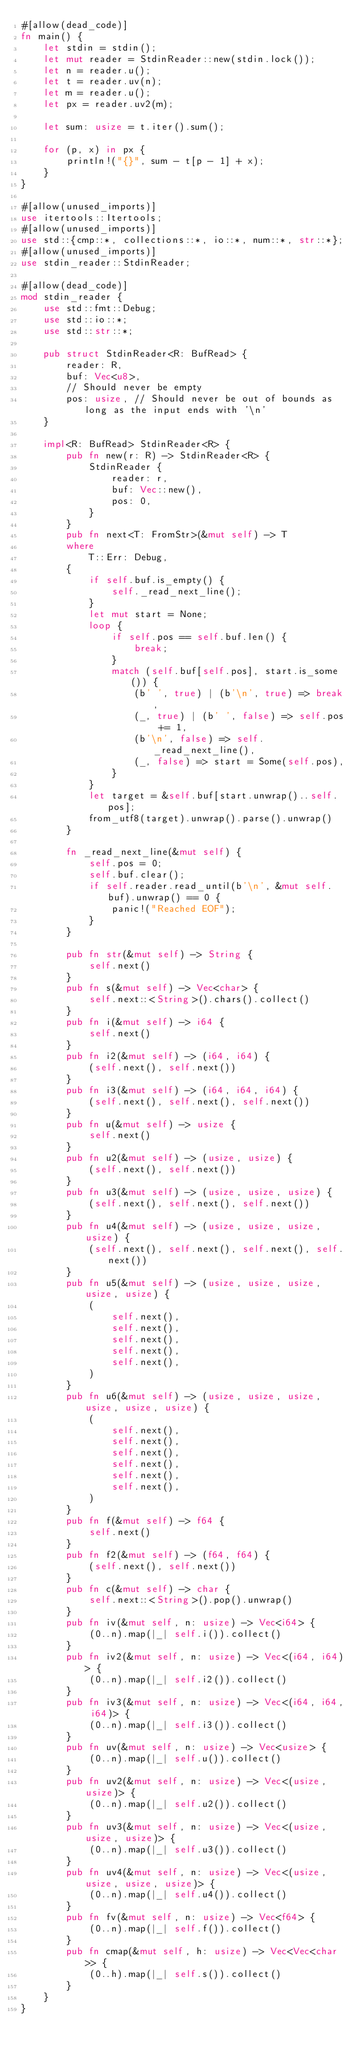Convert code to text. <code><loc_0><loc_0><loc_500><loc_500><_Rust_>#[allow(dead_code)]
fn main() {
    let stdin = stdin();
    let mut reader = StdinReader::new(stdin.lock());
    let n = reader.u();
    let t = reader.uv(n);
    let m = reader.u();
    let px = reader.uv2(m);

    let sum: usize = t.iter().sum();

    for (p, x) in px {
        println!("{}", sum - t[p - 1] + x);
    }
}

#[allow(unused_imports)]
use itertools::Itertools;
#[allow(unused_imports)]
use std::{cmp::*, collections::*, io::*, num::*, str::*};
#[allow(unused_imports)]
use stdin_reader::StdinReader;

#[allow(dead_code)]
mod stdin_reader {
    use std::fmt::Debug;
    use std::io::*;
    use std::str::*;

    pub struct StdinReader<R: BufRead> {
        reader: R,
        buf: Vec<u8>,
        // Should never be empty
        pos: usize, // Should never be out of bounds as long as the input ends with '\n'
    }

    impl<R: BufRead> StdinReader<R> {
        pub fn new(r: R) -> StdinReader<R> {
            StdinReader {
                reader: r,
                buf: Vec::new(),
                pos: 0,
            }
        }
        pub fn next<T: FromStr>(&mut self) -> T
        where
            T::Err: Debug,
        {
            if self.buf.is_empty() {
                self._read_next_line();
            }
            let mut start = None;
            loop {
                if self.pos == self.buf.len() {
                    break;
                }
                match (self.buf[self.pos], start.is_some()) {
                    (b' ', true) | (b'\n', true) => break,
                    (_, true) | (b' ', false) => self.pos += 1,
                    (b'\n', false) => self._read_next_line(),
                    (_, false) => start = Some(self.pos),
                }
            }
            let target = &self.buf[start.unwrap()..self.pos];
            from_utf8(target).unwrap().parse().unwrap()
        }

        fn _read_next_line(&mut self) {
            self.pos = 0;
            self.buf.clear();
            if self.reader.read_until(b'\n', &mut self.buf).unwrap() == 0 {
                panic!("Reached EOF");
            }
        }

        pub fn str(&mut self) -> String {
            self.next()
        }
        pub fn s(&mut self) -> Vec<char> {
            self.next::<String>().chars().collect()
        }
        pub fn i(&mut self) -> i64 {
            self.next()
        }
        pub fn i2(&mut self) -> (i64, i64) {
            (self.next(), self.next())
        }
        pub fn i3(&mut self) -> (i64, i64, i64) {
            (self.next(), self.next(), self.next())
        }
        pub fn u(&mut self) -> usize {
            self.next()
        }
        pub fn u2(&mut self) -> (usize, usize) {
            (self.next(), self.next())
        }
        pub fn u3(&mut self) -> (usize, usize, usize) {
            (self.next(), self.next(), self.next())
        }
        pub fn u4(&mut self) -> (usize, usize, usize, usize) {
            (self.next(), self.next(), self.next(), self.next())
        }
        pub fn u5(&mut self) -> (usize, usize, usize, usize, usize) {
            (
                self.next(),
                self.next(),
                self.next(),
                self.next(),
                self.next(),
            )
        }
        pub fn u6(&mut self) -> (usize, usize, usize, usize, usize, usize) {
            (
                self.next(),
                self.next(),
                self.next(),
                self.next(),
                self.next(),
                self.next(),
            )
        }
        pub fn f(&mut self) -> f64 {
            self.next()
        }
        pub fn f2(&mut self) -> (f64, f64) {
            (self.next(), self.next())
        }
        pub fn c(&mut self) -> char {
            self.next::<String>().pop().unwrap()
        }
        pub fn iv(&mut self, n: usize) -> Vec<i64> {
            (0..n).map(|_| self.i()).collect()
        }
        pub fn iv2(&mut self, n: usize) -> Vec<(i64, i64)> {
            (0..n).map(|_| self.i2()).collect()
        }
        pub fn iv3(&mut self, n: usize) -> Vec<(i64, i64, i64)> {
            (0..n).map(|_| self.i3()).collect()
        }
        pub fn uv(&mut self, n: usize) -> Vec<usize> {
            (0..n).map(|_| self.u()).collect()
        }
        pub fn uv2(&mut self, n: usize) -> Vec<(usize, usize)> {
            (0..n).map(|_| self.u2()).collect()
        }
        pub fn uv3(&mut self, n: usize) -> Vec<(usize, usize, usize)> {
            (0..n).map(|_| self.u3()).collect()
        }
        pub fn uv4(&mut self, n: usize) -> Vec<(usize, usize, usize, usize)> {
            (0..n).map(|_| self.u4()).collect()
        }
        pub fn fv(&mut self, n: usize) -> Vec<f64> {
            (0..n).map(|_| self.f()).collect()
        }
        pub fn cmap(&mut self, h: usize) -> Vec<Vec<char>> {
            (0..h).map(|_| self.s()).collect()
        }
    }
}
</code> 